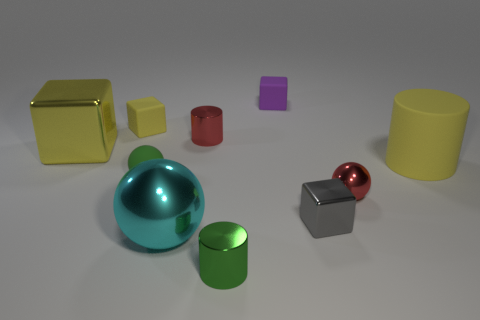There is a tiny cube that is the same color as the big matte thing; what is it made of?
Provide a succinct answer. Rubber. There is a yellow object on the right side of the metallic cylinder that is in front of the metallic cylinder that is behind the green ball; what is its size?
Your response must be concise. Large. How many cyan objects are in front of the purple thing?
Provide a succinct answer. 1. The big cylinder on the right side of the large yellow metal block on the left side of the big cyan metallic thing is made of what material?
Offer a very short reply. Rubber. Is the red metal sphere the same size as the yellow metal block?
Make the answer very short. No. What number of objects are either large metal objects in front of the large rubber cylinder or small cubes behind the green matte object?
Provide a succinct answer. 3. Is the number of large shiny things that are right of the tiny green sphere greater than the number of small yellow spheres?
Your answer should be compact. Yes. How many other things are there of the same shape as the tiny gray shiny thing?
Provide a succinct answer. 3. The tiny block that is both on the right side of the tiny yellow object and behind the tiny gray object is made of what material?
Your response must be concise. Rubber. How many things are tiny metallic balls or tiny brown rubber spheres?
Keep it short and to the point. 1. 